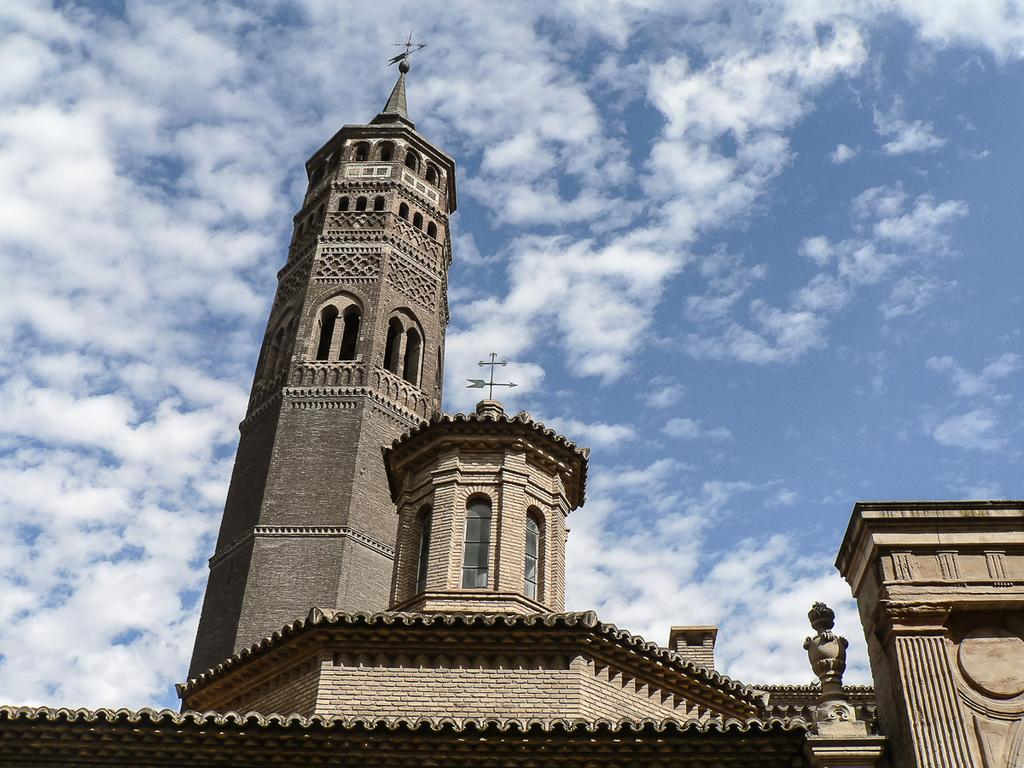What type of structure is present in the image? There is a building in the image. What can be seen in the background of the image? The sky is visible in the background of the image. What type of print is visible on the building's facade in the image? There is no specific print mentioned or visible on the building's facade in the image. 